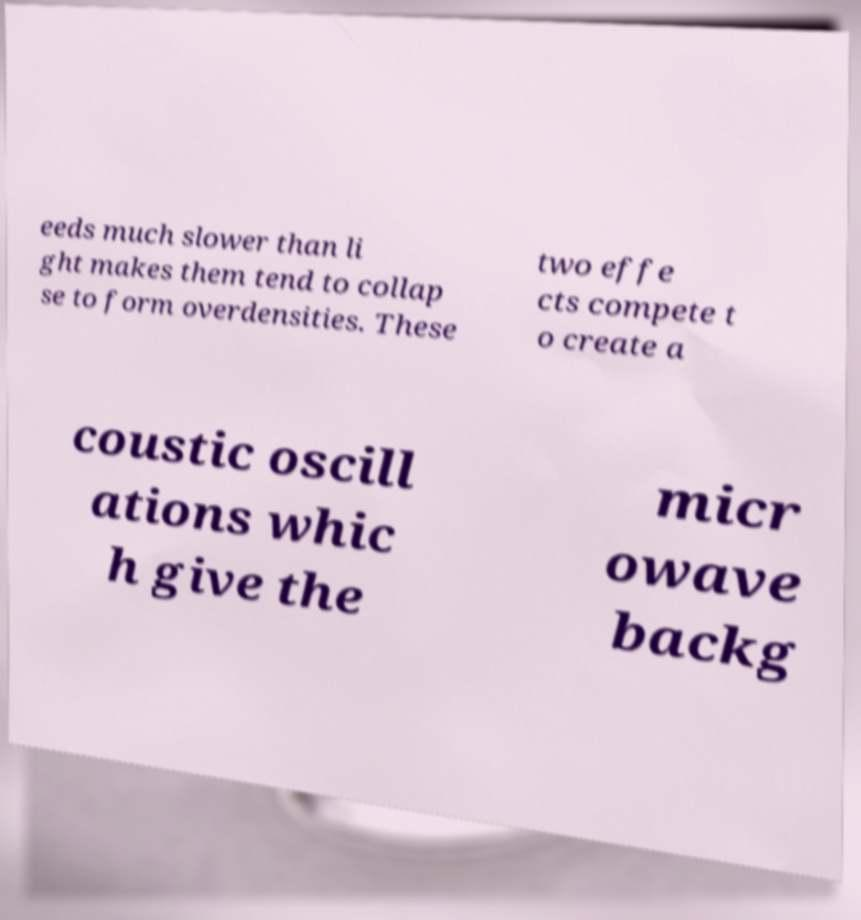There's text embedded in this image that I need extracted. Can you transcribe it verbatim? eeds much slower than li ght makes them tend to collap se to form overdensities. These two effe cts compete t o create a coustic oscill ations whic h give the micr owave backg 